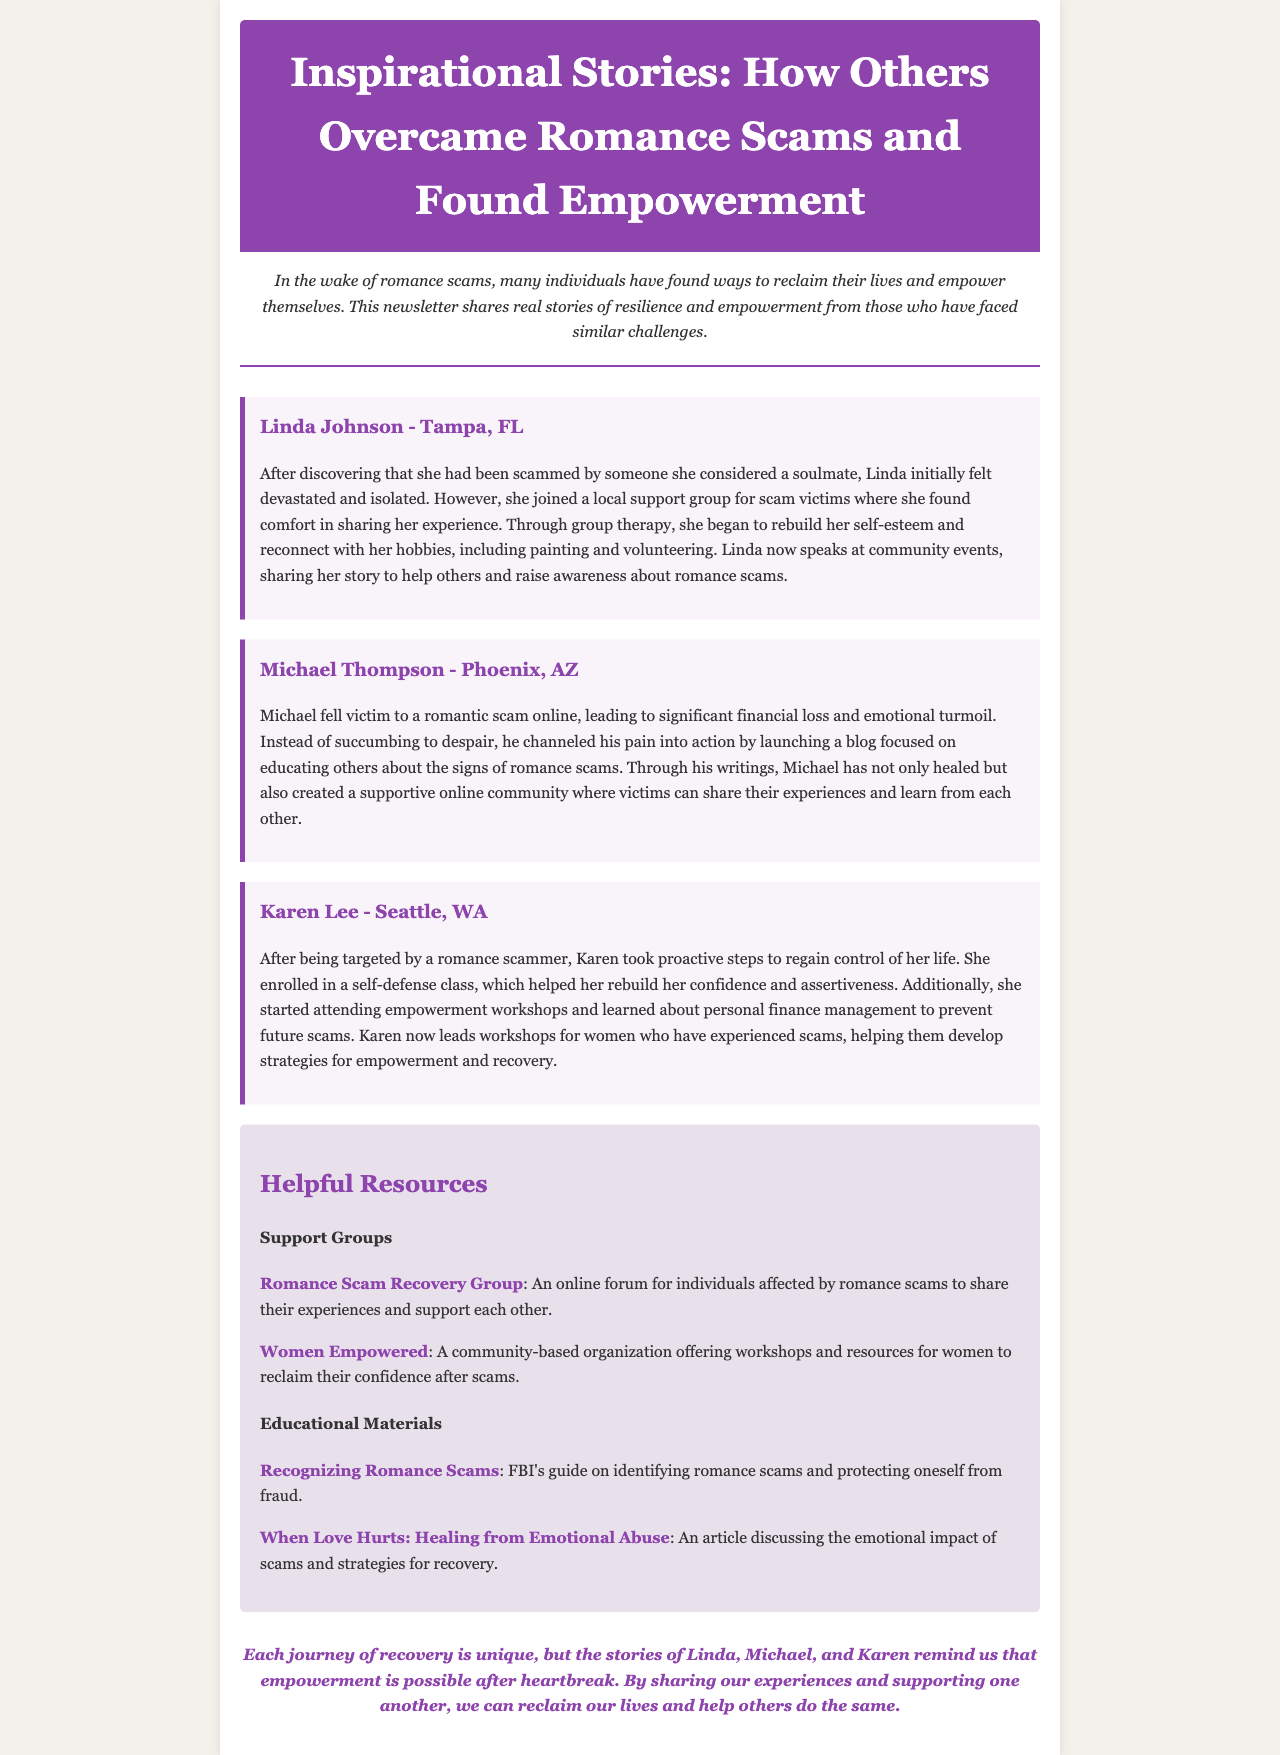What is the title of the newsletter? The title of the newsletter is prominently stated in the header section.
Answer: Inspirational Stories: How Others Overcame Romance Scams and Found Empowerment Who is the first person mentioned in the stories? The first person mentioned in the stories is introduced with their name and location.
Answer: Linda Johnson What city is Michael Thompson from? The city of Michael Thompson is listed in the story section.
Answer: Phoenix, AZ What type of class did Karen Lee enroll in? The type of class is specified in Karen's story about her proactive steps for recovery.
Answer: Self-defense class How many stories are shared in the newsletter? The number of stories is based on individual sections within the document.
Answer: Three What organization offers workshops for women? The organization providing workshops is identified within the resources section.
Answer: Women Empowered Which resource discusses the emotional impact of scams? The specific resource focusing on emotional impact is highlighted in the educational materials section.
Answer: When Love Hurts: Healing from Emotional Abuse What color is mentioned in the header of the document? The color in the header is described as a background color.
Answer: #8e44ad What type of document is this text part of? The overall category of the document is specified in the opening paragraph.
Answer: Newsletter 